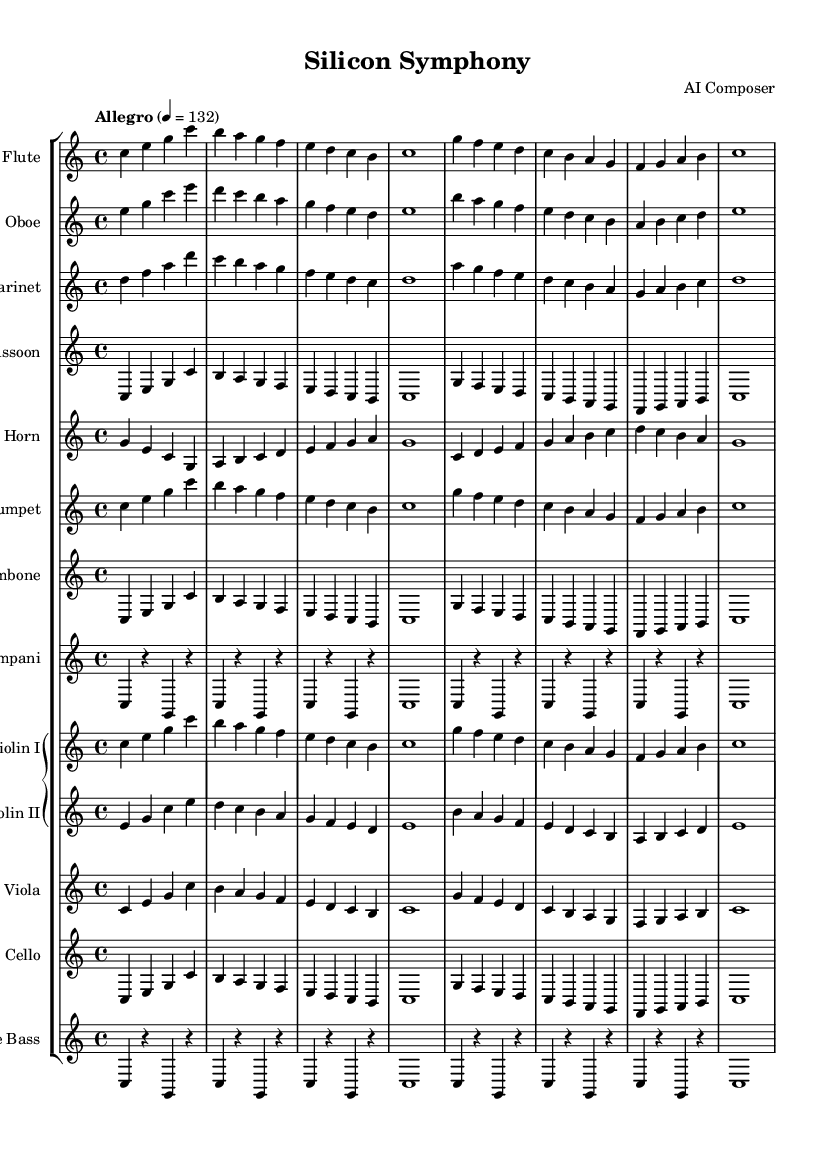What is the key signature of this music? The key signature is C major, which is indicated at the beginning of the score and has no sharps or flats.
Answer: C major What is the time signature of this composition? The time signature is shown at the beginning of the sheet music as 4/4, which means there are four beats per measure.
Answer: 4/4 What is the tempo marking for this symphony? The tempo marking, found at the beginning, indicates "Allegro" and the metronome marking is set to 132 beats per minute.
Answer: Allegro How many measures are there in the first section for the flute? The flute part has eight measures in the first section, as counted from the beginning to the end of the line.
Answer: Eight Which instruments are featured in the woodwind section? The woodwind section includes the flute, oboe, clarinet, and bassoon, as listed in their respective staves at the top of the score.
Answer: Flute, Oboe, Clarinet, Bassoon How does the melody progress in the first line for violin I? The melody for violin I progresses with ascending notes starting from C, with intervals that ascend and descend across the line comprised of quarter notes.
Answer: Ascending notes Which sections play a rhythm pattern on the timpani? The timpani part contains a rhythmic pattern that alternates between sustained notes and rests, giving a steady beat. This pattern is highlighted in both measures of the timpani section.
Answer: Timpani 